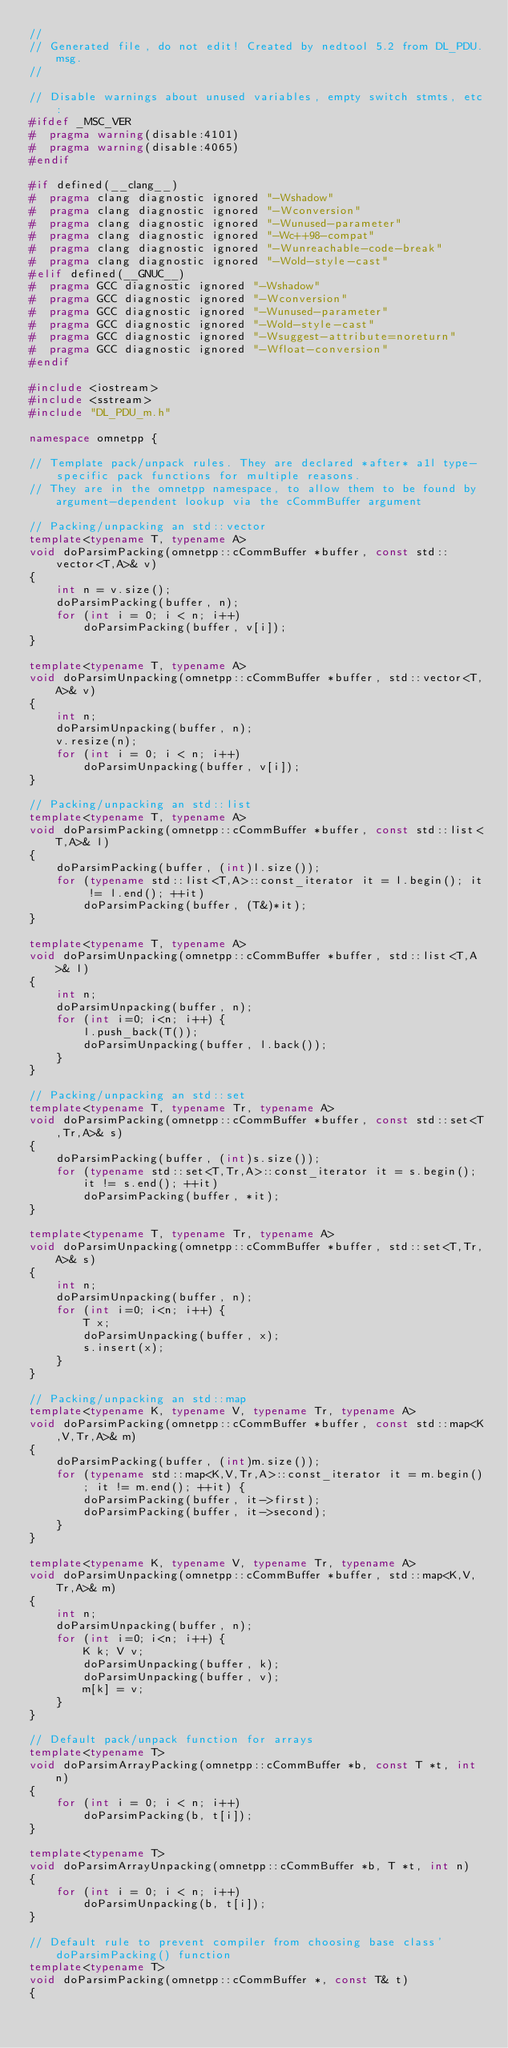<code> <loc_0><loc_0><loc_500><loc_500><_C++_>//
// Generated file, do not edit! Created by nedtool 5.2 from DL_PDU.msg.
//

// Disable warnings about unused variables, empty switch stmts, etc:
#ifdef _MSC_VER
#  pragma warning(disable:4101)
#  pragma warning(disable:4065)
#endif

#if defined(__clang__)
#  pragma clang diagnostic ignored "-Wshadow"
#  pragma clang diagnostic ignored "-Wconversion"
#  pragma clang diagnostic ignored "-Wunused-parameter"
#  pragma clang diagnostic ignored "-Wc++98-compat"
#  pragma clang diagnostic ignored "-Wunreachable-code-break"
#  pragma clang diagnostic ignored "-Wold-style-cast"
#elif defined(__GNUC__)
#  pragma GCC diagnostic ignored "-Wshadow"
#  pragma GCC diagnostic ignored "-Wconversion"
#  pragma GCC diagnostic ignored "-Wunused-parameter"
#  pragma GCC diagnostic ignored "-Wold-style-cast"
#  pragma GCC diagnostic ignored "-Wsuggest-attribute=noreturn"
#  pragma GCC diagnostic ignored "-Wfloat-conversion"
#endif

#include <iostream>
#include <sstream>
#include "DL_PDU_m.h"

namespace omnetpp {

// Template pack/unpack rules. They are declared *after* a1l type-specific pack functions for multiple reasons.
// They are in the omnetpp namespace, to allow them to be found by argument-dependent lookup via the cCommBuffer argument

// Packing/unpacking an std::vector
template<typename T, typename A>
void doParsimPacking(omnetpp::cCommBuffer *buffer, const std::vector<T,A>& v)
{
    int n = v.size();
    doParsimPacking(buffer, n);
    for (int i = 0; i < n; i++)
        doParsimPacking(buffer, v[i]);
}

template<typename T, typename A>
void doParsimUnpacking(omnetpp::cCommBuffer *buffer, std::vector<T,A>& v)
{
    int n;
    doParsimUnpacking(buffer, n);
    v.resize(n);
    for (int i = 0; i < n; i++)
        doParsimUnpacking(buffer, v[i]);
}

// Packing/unpacking an std::list
template<typename T, typename A>
void doParsimPacking(omnetpp::cCommBuffer *buffer, const std::list<T,A>& l)
{
    doParsimPacking(buffer, (int)l.size());
    for (typename std::list<T,A>::const_iterator it = l.begin(); it != l.end(); ++it)
        doParsimPacking(buffer, (T&)*it);
}

template<typename T, typename A>
void doParsimUnpacking(omnetpp::cCommBuffer *buffer, std::list<T,A>& l)
{
    int n;
    doParsimUnpacking(buffer, n);
    for (int i=0; i<n; i++) {
        l.push_back(T());
        doParsimUnpacking(buffer, l.back());
    }
}

// Packing/unpacking an std::set
template<typename T, typename Tr, typename A>
void doParsimPacking(omnetpp::cCommBuffer *buffer, const std::set<T,Tr,A>& s)
{
    doParsimPacking(buffer, (int)s.size());
    for (typename std::set<T,Tr,A>::const_iterator it = s.begin(); it != s.end(); ++it)
        doParsimPacking(buffer, *it);
}

template<typename T, typename Tr, typename A>
void doParsimUnpacking(omnetpp::cCommBuffer *buffer, std::set<T,Tr,A>& s)
{
    int n;
    doParsimUnpacking(buffer, n);
    for (int i=0; i<n; i++) {
        T x;
        doParsimUnpacking(buffer, x);
        s.insert(x);
    }
}

// Packing/unpacking an std::map
template<typename K, typename V, typename Tr, typename A>
void doParsimPacking(omnetpp::cCommBuffer *buffer, const std::map<K,V,Tr,A>& m)
{
    doParsimPacking(buffer, (int)m.size());
    for (typename std::map<K,V,Tr,A>::const_iterator it = m.begin(); it != m.end(); ++it) {
        doParsimPacking(buffer, it->first);
        doParsimPacking(buffer, it->second);
    }
}

template<typename K, typename V, typename Tr, typename A>
void doParsimUnpacking(omnetpp::cCommBuffer *buffer, std::map<K,V,Tr,A>& m)
{
    int n;
    doParsimUnpacking(buffer, n);
    for (int i=0; i<n; i++) {
        K k; V v;
        doParsimUnpacking(buffer, k);
        doParsimUnpacking(buffer, v);
        m[k] = v;
    }
}

// Default pack/unpack function for arrays
template<typename T>
void doParsimArrayPacking(omnetpp::cCommBuffer *b, const T *t, int n)
{
    for (int i = 0; i < n; i++)
        doParsimPacking(b, t[i]);
}

template<typename T>
void doParsimArrayUnpacking(omnetpp::cCommBuffer *b, T *t, int n)
{
    for (int i = 0; i < n; i++)
        doParsimUnpacking(b, t[i]);
}

// Default rule to prevent compiler from choosing base class' doParsimPacking() function
template<typename T>
void doParsimPacking(omnetpp::cCommBuffer *, const T& t)
{</code> 